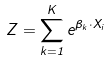Convert formula to latex. <formula><loc_0><loc_0><loc_500><loc_500>Z = \sum _ { k = 1 } ^ { K } e ^ { \beta _ { k } \cdot X _ { i } }</formula> 